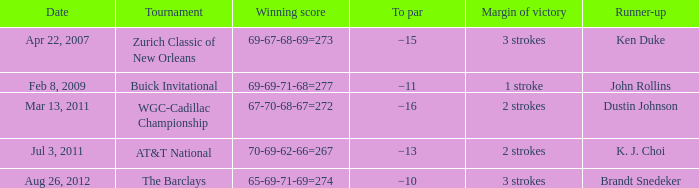What is the date when the successful score of 67-70-68-67=272 was achieved? Mar 13, 2011. 